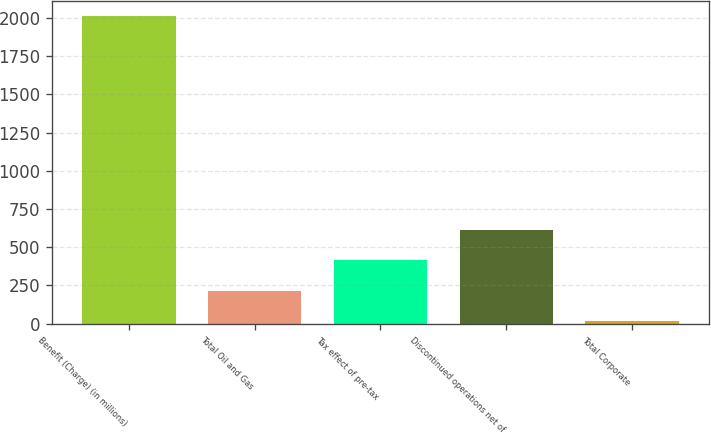Convert chart. <chart><loc_0><loc_0><loc_500><loc_500><bar_chart><fcel>Benefit (Charge) (in millions)<fcel>Total Oil and Gas<fcel>Tax effect of pre-tax<fcel>Discontinued operations net of<fcel>Total Corporate<nl><fcel>2011<fcel>214.6<fcel>414.2<fcel>613.8<fcel>15<nl></chart> 